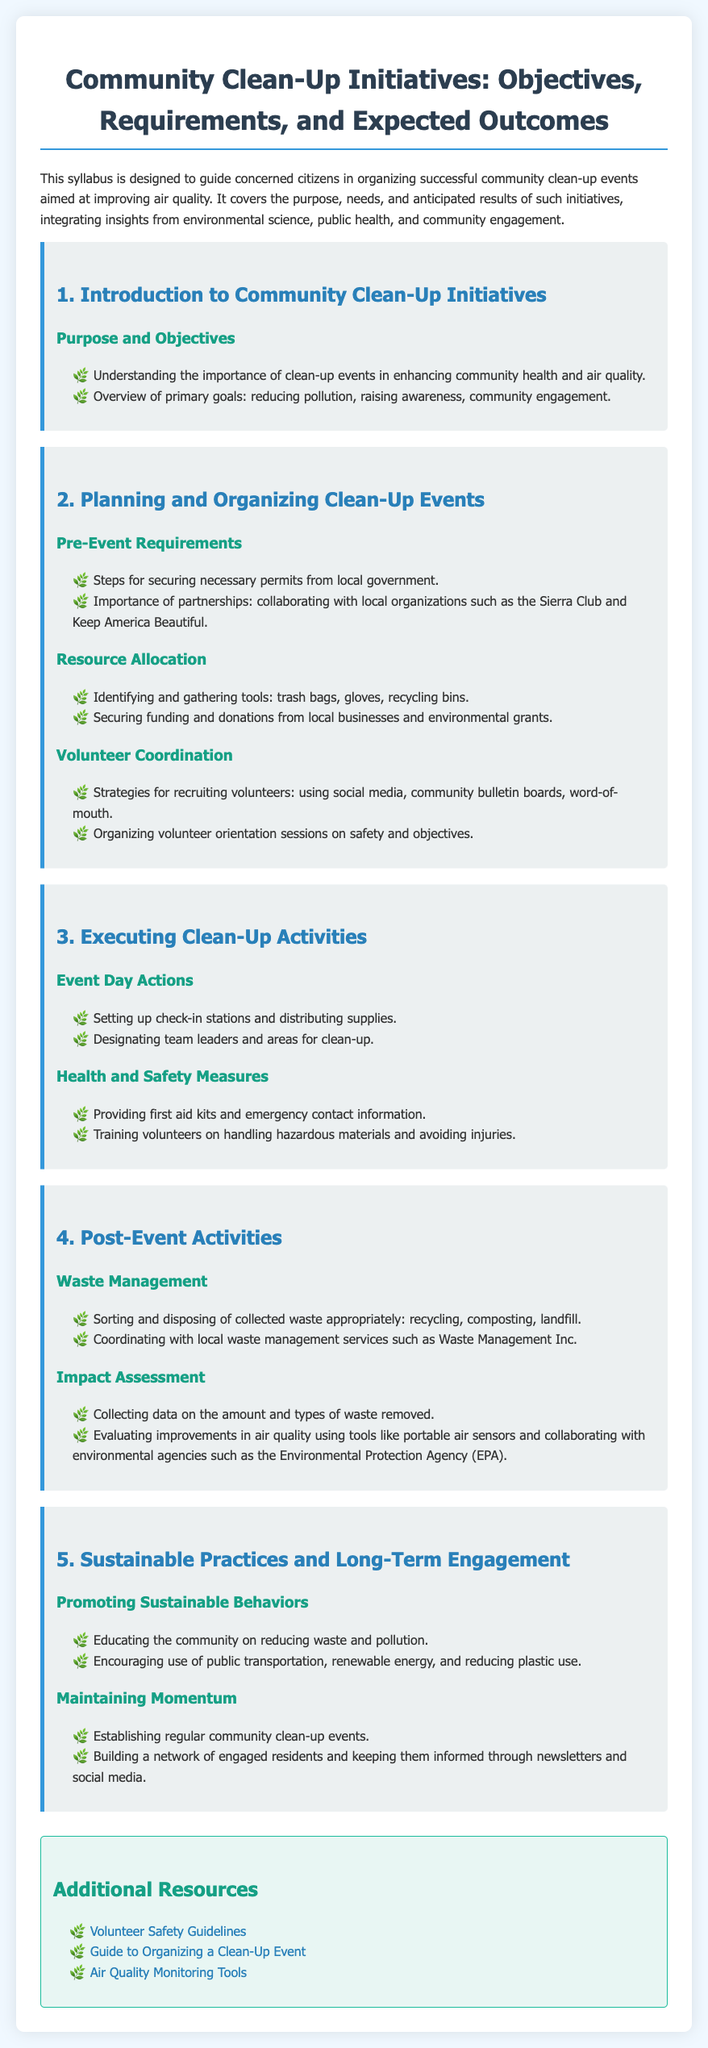What is the main purpose of the syllabus? The main purpose is to guide concerned citizens in organizing successful community clean-up events aimed at improving air quality.
Answer: To guide citizens in organizing clean-up events What is one of the primary goals of clean-up events? One of the primary goals mentioned in the syllabus is to reduce pollution.
Answer: Reducing pollution Which organization is suggested for collaboration when planning clean-up events? The syllabus suggests collaborating with local organizations such as the Sierra Club.
Answer: Sierra Club What should be provided on event day for health and safety measures? The syllabus states that first aid kits should be provided on event day.
Answer: First aid kits How can volunteers be recruited according to the syllabus? Volunteers can be recruited using social media, community bulletin boards, and word-of-mouth.
Answer: Social media What is one of the post-event activities mentioned in the syllabus? One of the post-event activities is sorting and disposing of collected waste appropriately.
Answer: Sorting waste Which tool is mentioned for evaluating improvements in air quality? Portable air sensors are mentioned for evaluating improvements in air quality.
Answer: Portable air sensors What is emphasized for sustaining clean-up initiatives in the community? The syllabus emphasizes establishing regular community clean-up events.
Answer: Regular clean-up events 